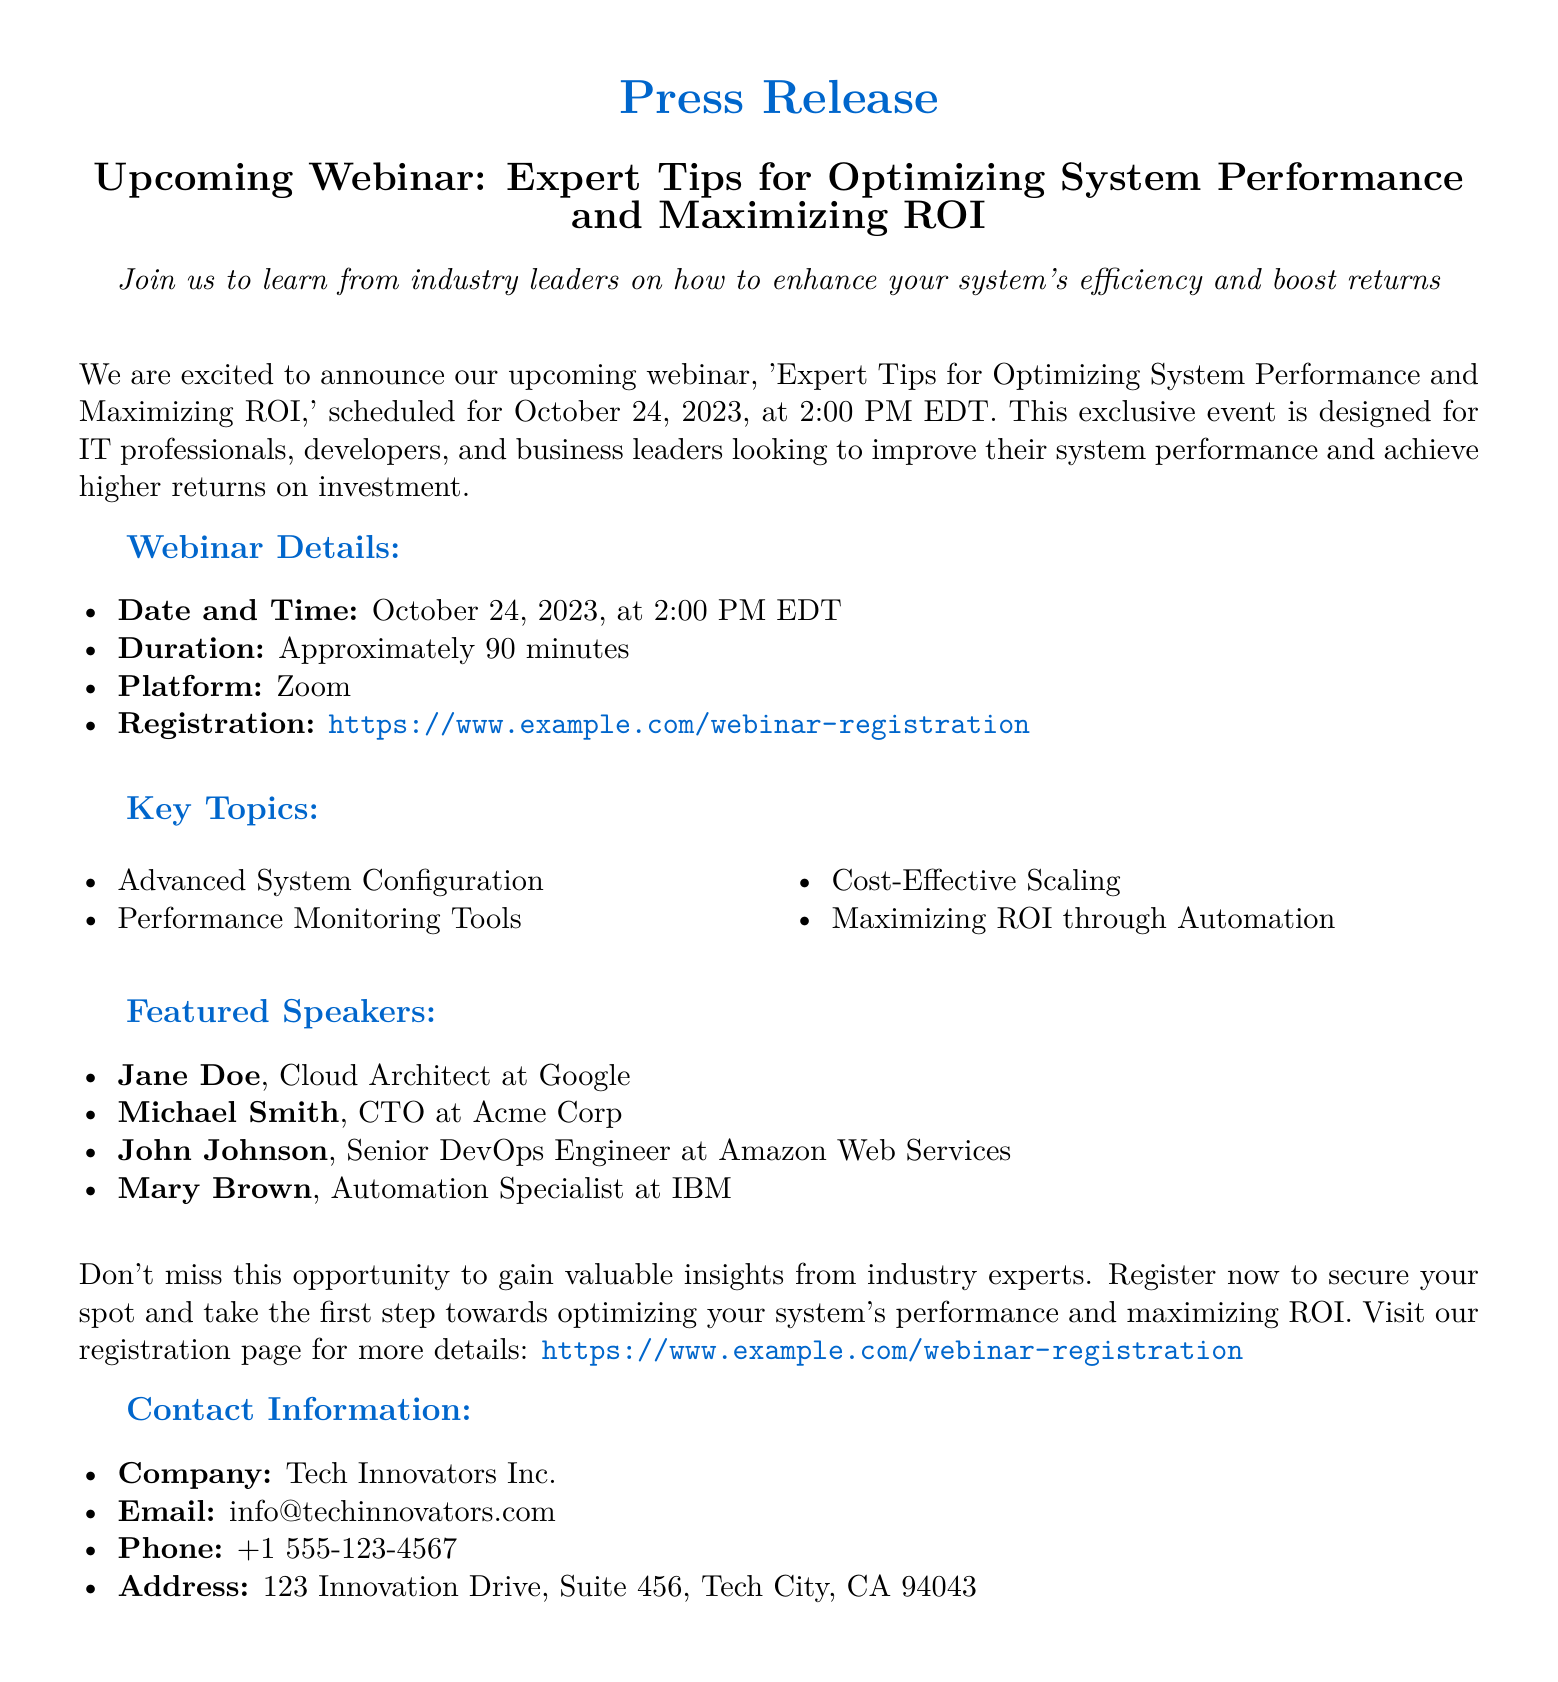What is the date of the webinar? The date of the webinar is explicitly mentioned in the document.
Answer: October 24, 2023 What time does the webinar start? The starting time is clearly stated in the details section of the document.
Answer: 2:00 PM EDT How long is the webinar scheduled to last? The duration of the webinar is specified within the document.
Answer: Approximately 90 minutes Who is the Cloud Architect featured in the webinar? This information is found in the featured speakers section of the document.
Answer: Jane Doe What platform will the webinar be held on? The document provides the platform information for the webinar.
Answer: Zoom What is one of the key topics discussed in the webinar? A selection of topics is listed in the document.
Answer: Advanced System Configuration Which company is hosting the webinar? The hosting company is mentioned in the contact information section.
Answer: Tech Innovators Inc What is the registration link for the webinar? The document includes a direct URL for registration.
Answer: https://www.example.com/webinar-registration Who can benefit from attending this webinar? The document indicates the target audience for the webinar.
Answer: IT professionals, developers, and business leaders 